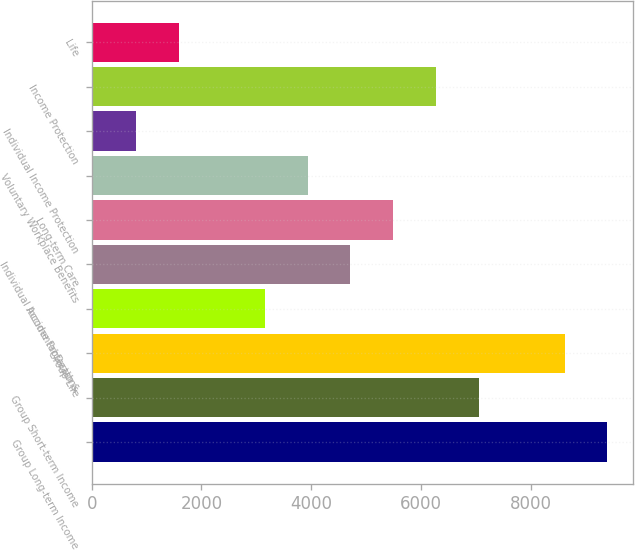Convert chart to OTSL. <chart><loc_0><loc_0><loc_500><loc_500><bar_chart><fcel>Group Long-term Income<fcel>Group Short-term Income<fcel>Group Life<fcel>Accidental Death &<fcel>Individual Income Protection -<fcel>Long-term Care<fcel>Voluntary Workplace Benefits<fcel>Individual Income Protection<fcel>Income Protection<fcel>Life<nl><fcel>9401.26<fcel>7058.77<fcel>8620.43<fcel>3154.62<fcel>4716.28<fcel>5497.11<fcel>3935.45<fcel>812.13<fcel>6277.94<fcel>1592.96<nl></chart> 